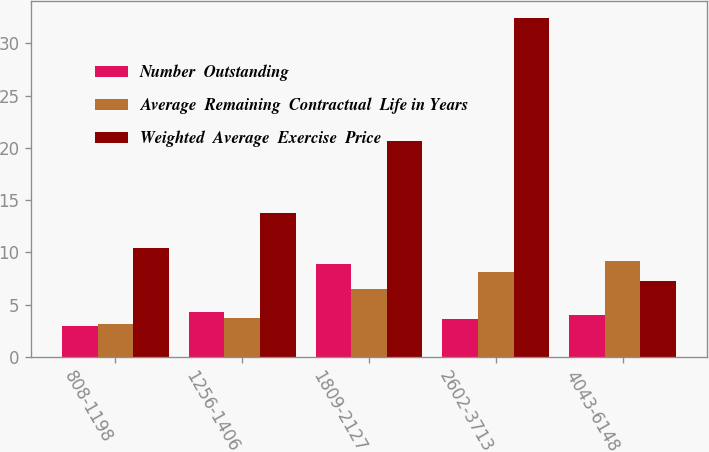Convert chart. <chart><loc_0><loc_0><loc_500><loc_500><stacked_bar_chart><ecel><fcel>808-1198<fcel>1256-1406<fcel>1809-2127<fcel>2602-3713<fcel>4043-6148<nl><fcel>Number  Outstanding<fcel>2.9<fcel>4.3<fcel>8.9<fcel>3.6<fcel>4<nl><fcel>Average  Remaining  Contractual  Life in Years<fcel>3.1<fcel>3.7<fcel>6.5<fcel>8.1<fcel>9.2<nl><fcel>Weighted  Average  Exercise  Price<fcel>10.41<fcel>13.76<fcel>20.66<fcel>32.41<fcel>7.3<nl></chart> 